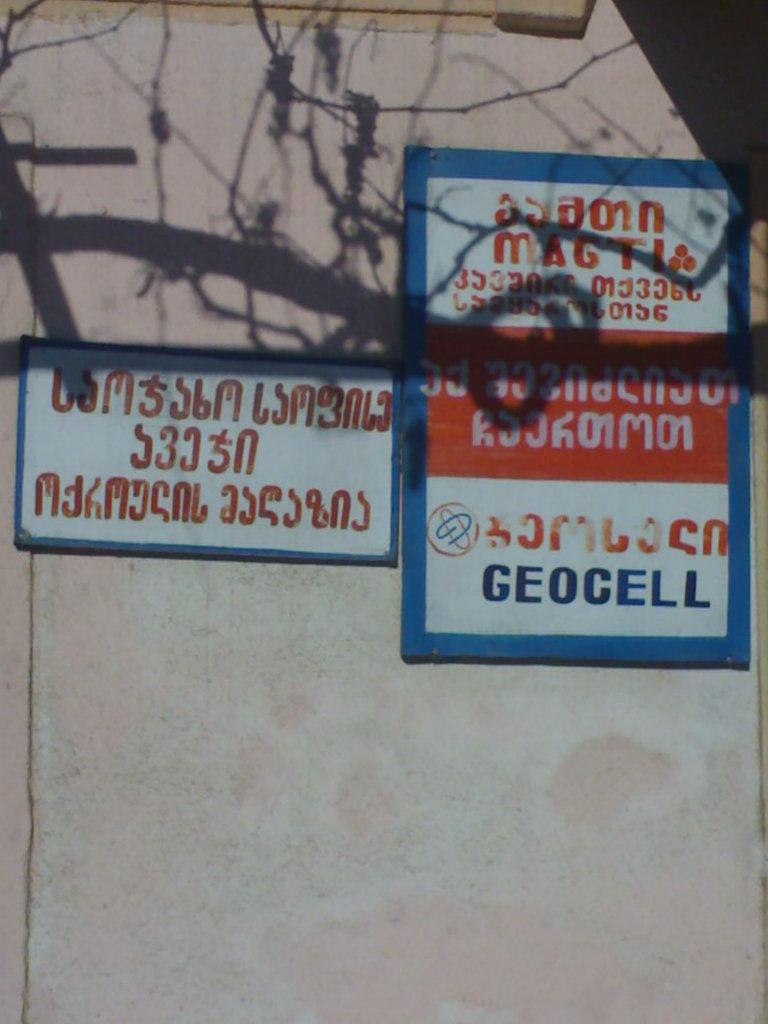<image>
Share a concise interpretation of the image provided. Signs in a different language on a wall and one says GEOCELL. 